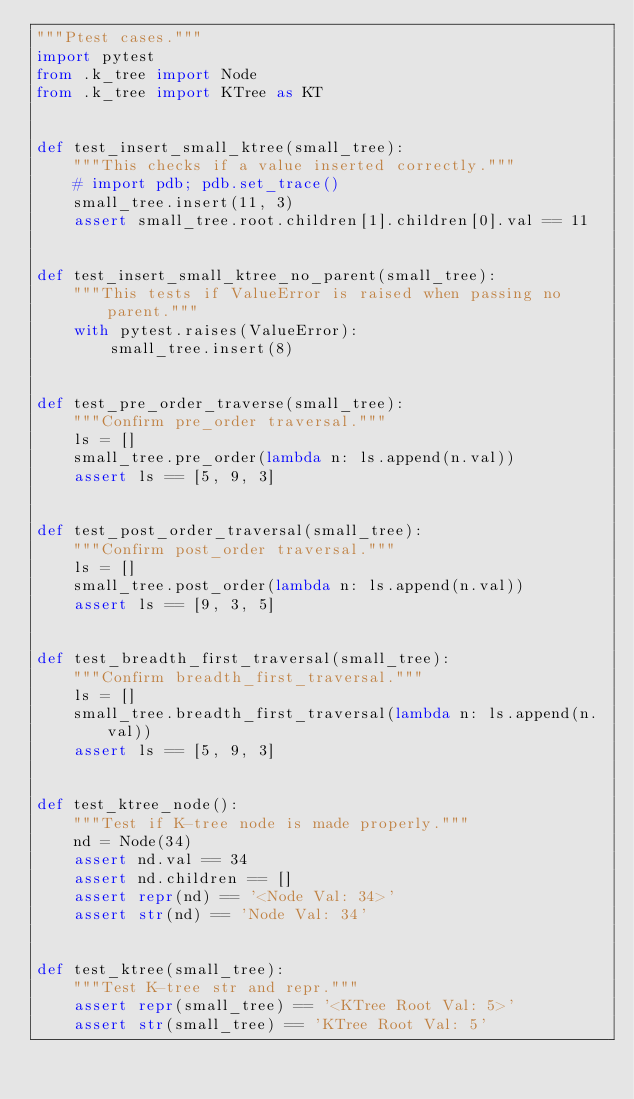Convert code to text. <code><loc_0><loc_0><loc_500><loc_500><_Python_>"""Ptest cases."""
import pytest
from .k_tree import Node
from .k_tree import KTree as KT


def test_insert_small_ktree(small_tree):
    """This checks if a value inserted correctly."""
    # import pdb; pdb.set_trace()
    small_tree.insert(11, 3)
    assert small_tree.root.children[1].children[0].val == 11


def test_insert_small_ktree_no_parent(small_tree):
    """This tests if ValueError is raised when passing no parent."""
    with pytest.raises(ValueError):
        small_tree.insert(8)


def test_pre_order_traverse(small_tree):
    """Confirm pre_order traversal."""
    ls = []
    small_tree.pre_order(lambda n: ls.append(n.val))
    assert ls == [5, 9, 3]


def test_post_order_traversal(small_tree):
    """Confirm post_order traversal."""
    ls = []
    small_tree.post_order(lambda n: ls.append(n.val))
    assert ls == [9, 3, 5]


def test_breadth_first_traversal(small_tree):
    """Confirm breadth_first_traversal."""
    ls = []
    small_tree.breadth_first_traversal(lambda n: ls.append(n.val))
    assert ls == [5, 9, 3]


def test_ktree_node():
    """Test if K-tree node is made properly."""
    nd = Node(34)
    assert nd.val == 34
    assert nd.children == []
    assert repr(nd) == '<Node Val: 34>'
    assert str(nd) == 'Node Val: 34'


def test_ktree(small_tree):
    """Test K-tree str and repr."""
    assert repr(small_tree) == '<KTree Root Val: 5>'
    assert str(small_tree) == 'KTree Root Val: 5'
</code> 